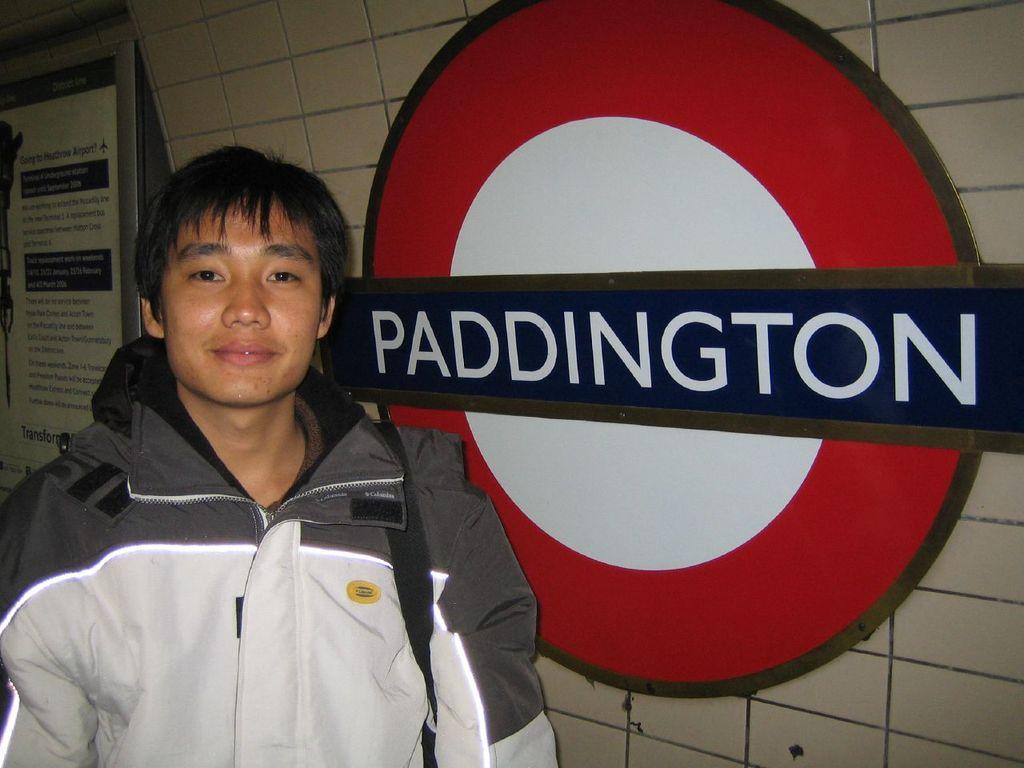<image>
Render a clear and concise summary of the photo. A young man in the London Underground stands next to a Paddington sign. 